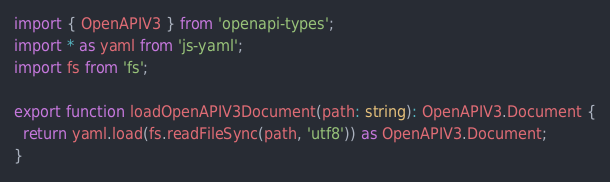<code> <loc_0><loc_0><loc_500><loc_500><_TypeScript_>import { OpenAPIV3 } from 'openapi-types';
import * as yaml from 'js-yaml';
import fs from 'fs';

export function loadOpenAPIV3Document(path: string): OpenAPIV3.Document {
  return yaml.load(fs.readFileSync(path, 'utf8')) as OpenAPIV3.Document;
}
</code> 